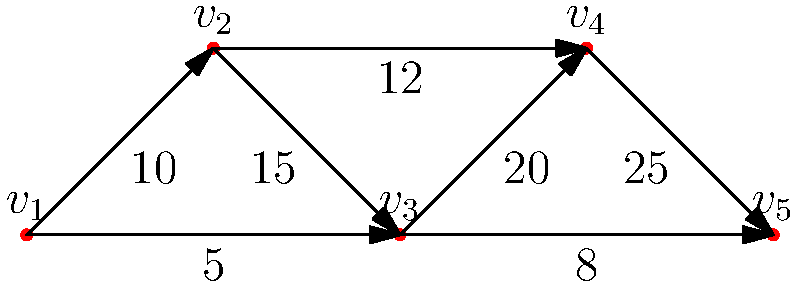In the directed graph representing money laundering patterns, where vertices represent entities and weighted edges represent transactions in thousands of dollars, what is the total amount of money laundered through the path with the highest cumulative transaction value? To find the path with the highest cumulative transaction value, we need to:

1. Identify all possible paths from the source (v1) to the sink (v5).
2. Calculate the total transaction value for each path.
3. Compare the totals and select the highest.

Possible paths:
1. v1 → v2 → v3 → v4 → v5
2. v1 → v2 → v3 → v5
3. v1 → v3 → v4 → v5
4. v1 → v3 → v5

Calculating totals:
1. v1 → v2 → v3 → v4 → v5: $10 + 15 + 20 + 25 = 70$ thousand
2. v1 → v2 → v3 → v5: $10 + 15 + 8 = 33$ thousand
3. v1 → v3 → v4 → v5: $5 + 20 + 25 = 50$ thousand
4. v1 → v3 → v5: $5 + 8 = 13$ thousand

The path with the highest cumulative transaction value is v1 → v2 → v3 → v4 → v5, with a total of $70,000.
Answer: $70,000 